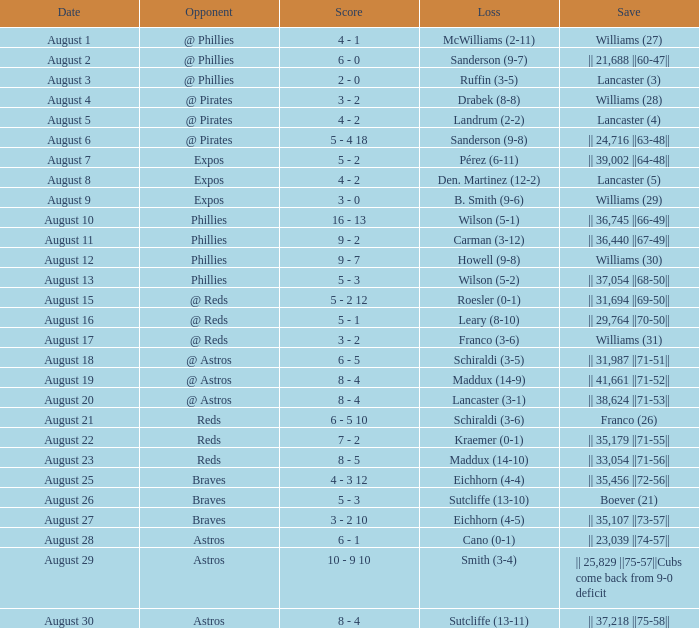Identify the save score for lancaster (3) 2 - 0. 